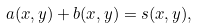Convert formula to latex. <formula><loc_0><loc_0><loc_500><loc_500>a ( x , y ) + b ( x , y ) = s ( x , y ) ,</formula> 